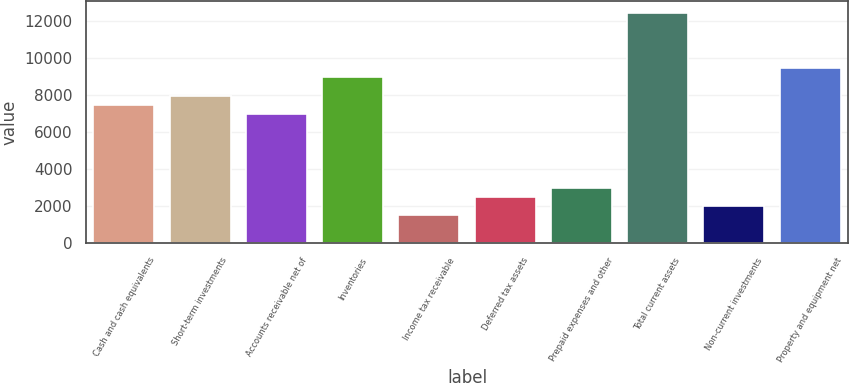<chart> <loc_0><loc_0><loc_500><loc_500><bar_chart><fcel>Cash and cash equivalents<fcel>Short-term investments<fcel>Accounts receivable net of<fcel>Inventories<fcel>Income tax receivable<fcel>Deferred tax assets<fcel>Prepaid expenses and other<fcel>Total current assets<fcel>Non-current investments<fcel>Property and equipment net<nl><fcel>7471.5<fcel>7969.58<fcel>6973.42<fcel>8965.74<fcel>1494.54<fcel>2490.7<fcel>2988.78<fcel>12452.3<fcel>1992.62<fcel>9463.82<nl></chart> 